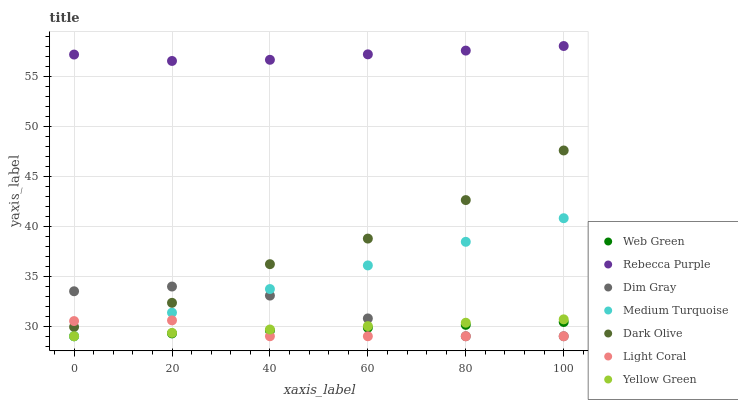Does Light Coral have the minimum area under the curve?
Answer yes or no. Yes. Does Rebecca Purple have the maximum area under the curve?
Answer yes or no. Yes. Does Yellow Green have the minimum area under the curve?
Answer yes or no. No. Does Yellow Green have the maximum area under the curve?
Answer yes or no. No. Is Yellow Green the smoothest?
Answer yes or no. Yes. Is Dark Olive the roughest?
Answer yes or no. Yes. Is Dark Olive the smoothest?
Answer yes or no. No. Is Yellow Green the roughest?
Answer yes or no. No. Does Dim Gray have the lowest value?
Answer yes or no. Yes. Does Dark Olive have the lowest value?
Answer yes or no. No. Does Rebecca Purple have the highest value?
Answer yes or no. Yes. Does Yellow Green have the highest value?
Answer yes or no. No. Is Dim Gray less than Rebecca Purple?
Answer yes or no. Yes. Is Rebecca Purple greater than Yellow Green?
Answer yes or no. Yes. Does Medium Turquoise intersect Web Green?
Answer yes or no. Yes. Is Medium Turquoise less than Web Green?
Answer yes or no. No. Is Medium Turquoise greater than Web Green?
Answer yes or no. No. Does Dim Gray intersect Rebecca Purple?
Answer yes or no. No. 